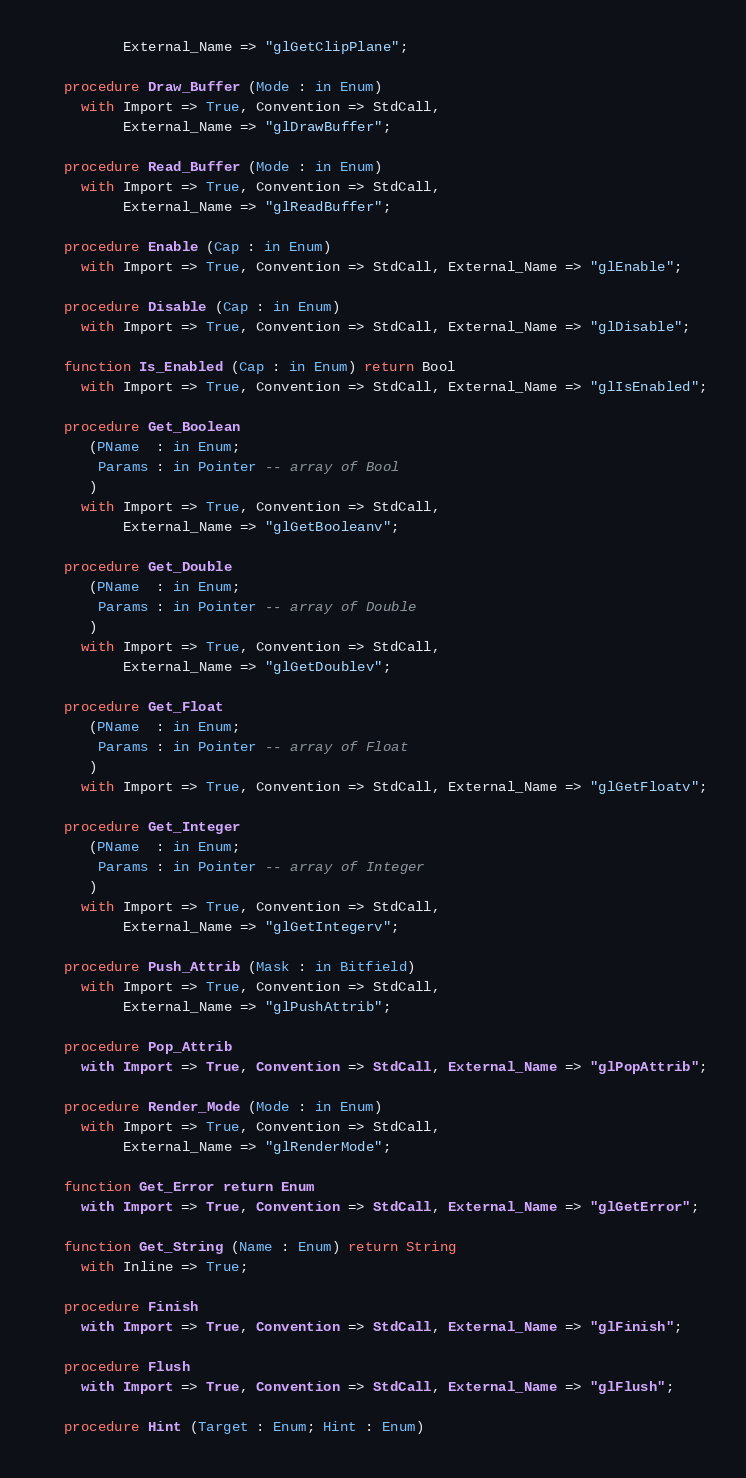<code> <loc_0><loc_0><loc_500><loc_500><_Ada_>          External_Name => "glGetClipPlane";

   procedure Draw_Buffer (Mode : in Enum)
     with Import => True, Convention => StdCall,
          External_Name => "glDrawBuffer";

   procedure Read_Buffer (Mode : in Enum)
     with Import => True, Convention => StdCall,
          External_Name => "glReadBuffer";

   procedure Enable (Cap : in Enum)
     with Import => True, Convention => StdCall, External_Name => "glEnable";

   procedure Disable (Cap : in Enum)
     with Import => True, Convention => StdCall, External_Name => "glDisable";

   function Is_Enabled (Cap : in Enum) return Bool
     with Import => True, Convention => StdCall, External_Name => "glIsEnabled";

   procedure Get_Boolean
      (PName  : in Enum;
       Params : in Pointer -- array of Bool
      )
     with Import => True, Convention => StdCall,
          External_Name => "glGetBooleanv";

   procedure Get_Double
      (PName  : in Enum;
       Params : in Pointer -- array of Double
      )
     with Import => True, Convention => StdCall,
          External_Name => "glGetDoublev";

   procedure Get_Float
      (PName  : in Enum;
       Params : in Pointer -- array of Float
      )
     with Import => True, Convention => StdCall, External_Name => "glGetFloatv";

   procedure Get_Integer
      (PName  : in Enum;
       Params : in Pointer -- array of Integer
      )
     with Import => True, Convention => StdCall,
          External_Name => "glGetIntegerv";

   procedure Push_Attrib (Mask : in Bitfield)
     with Import => True, Convention => StdCall,
          External_Name => "glPushAttrib";

   procedure Pop_Attrib
     with Import => True, Convention => StdCall, External_Name => "glPopAttrib";

   procedure Render_Mode (Mode : in Enum)
     with Import => True, Convention => StdCall,
          External_Name => "glRenderMode";

   function Get_Error return Enum
     with Import => True, Convention => StdCall, External_Name => "glGetError";

   function Get_String (Name : Enum) return String
     with Inline => True;

   procedure Finish
     with Import => True, Convention => StdCall, External_Name => "glFinish";

   procedure Flush
     with Import => True, Convention => StdCall, External_Name => "glFlush";

   procedure Hint (Target : Enum; Hint : Enum)</code> 